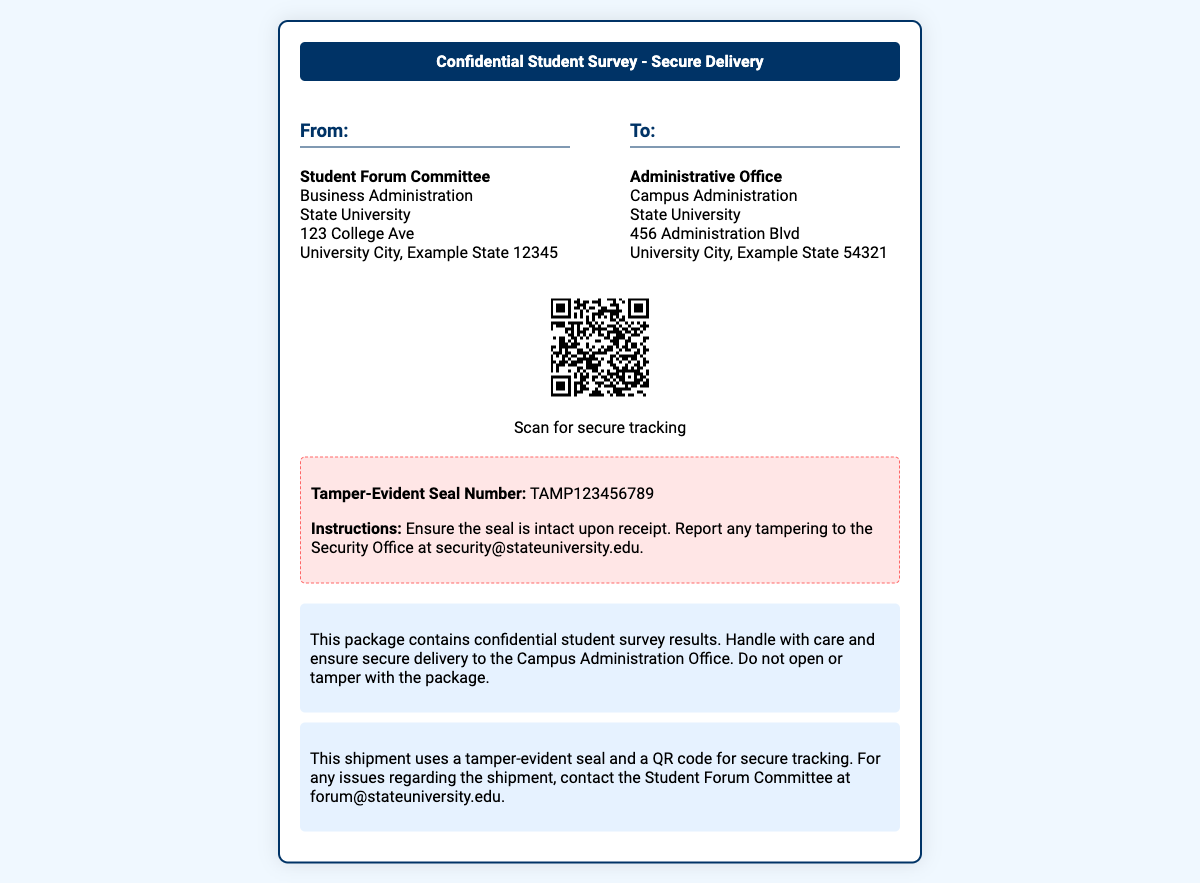What is the sender's address? The sender's address is listed under "From." It is the location of the Student Forum Committee at State University, 123 College Ave, University City, Example State 12345.
Answer: 123 College Ave, University City, Example State 12345 What is the tamper-evident seal number? The tamper-evident seal number is mentioned in the tamper-seal section of the document.
Answer: TAMP123456789 What is the recipient's title? The recipient's title is given under "To." It specifies the Administrative Office.
Answer: Administrative Office What should be done if the tamper seal is broken? The instructions are found in the tamper-seal section, stating to report any tampering to the Security Office.
Answer: Report to the Security Office What does the QR code provide? The QR code's purpose is stated near it, indicating that it allows for secure tracking.
Answer: Secure tracking Why is this package labeled "confidential"? The description section indicates it contains confidential student survey results, which restricts access and handling.
Answer: Confidential student survey results How should the package be handled? The description mentions that the package should be handled with care and not opened or tampered with.
Answer: Handle with care Who should be contacted for shipment issues? The security notice specifies the contact for shipment issues is the Student Forum Committee.
Answer: Student Forum Committee What color is the header of the shipping label? The header is described in the style section, stating it has a background color of dark blue.
Answer: Dark blue 